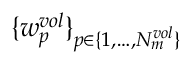<formula> <loc_0><loc_0><loc_500><loc_500>\{ w _ { p } ^ { v o l } \} _ { p \in \{ 1 , \dots , N _ { m } ^ { v o l } \} }</formula> 